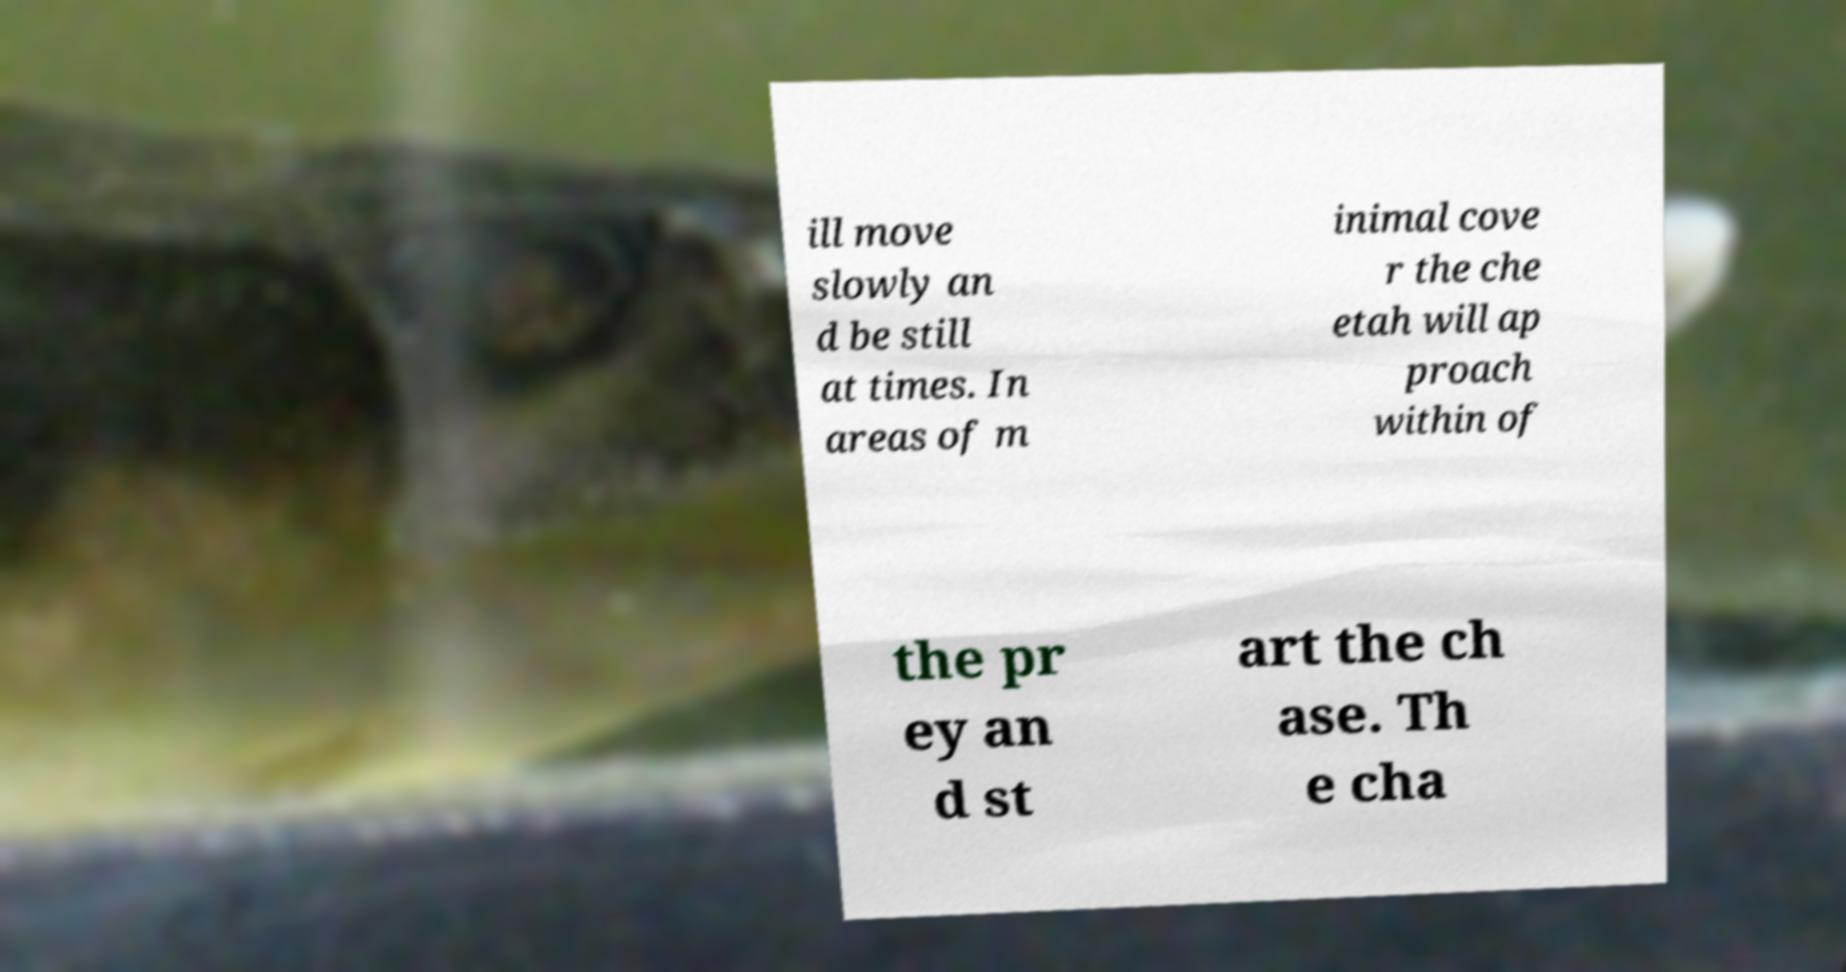What messages or text are displayed in this image? I need them in a readable, typed format. ill move slowly an d be still at times. In areas of m inimal cove r the che etah will ap proach within of the pr ey an d st art the ch ase. Th e cha 